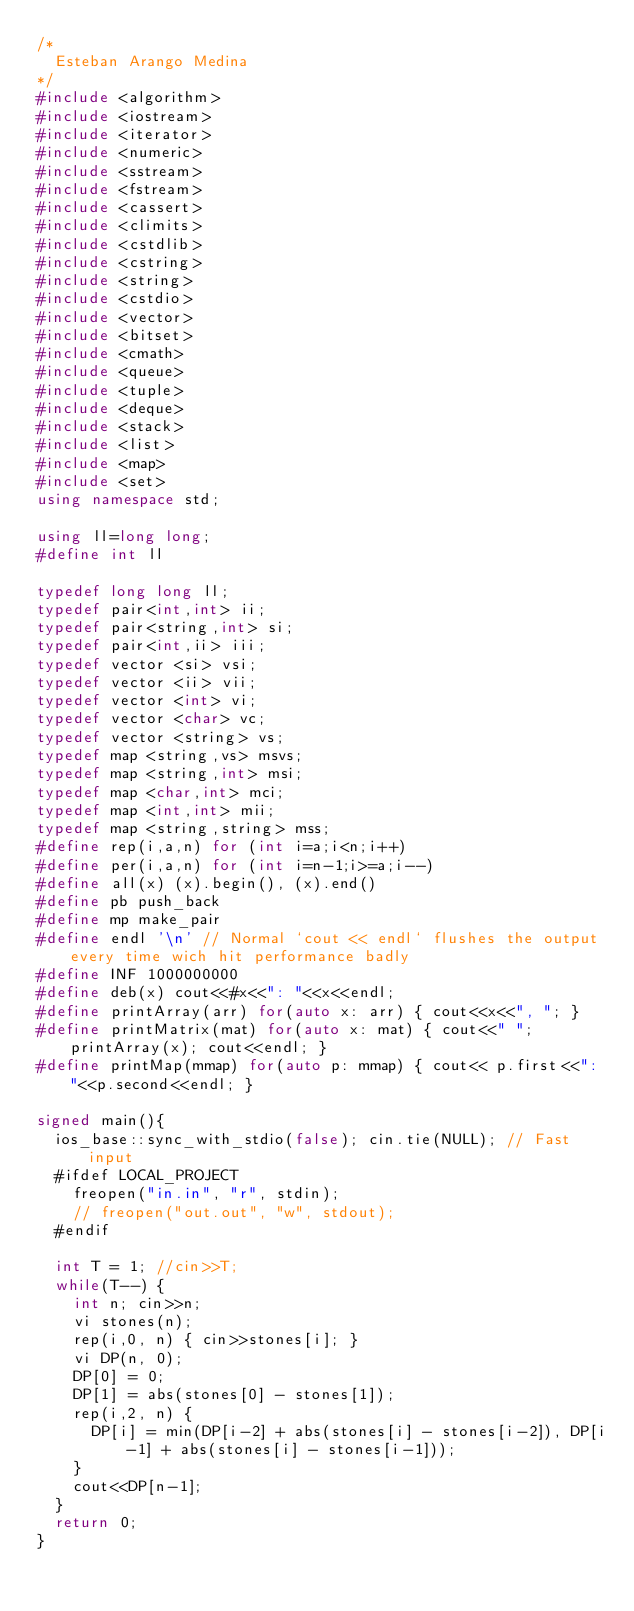<code> <loc_0><loc_0><loc_500><loc_500><_C++_>/*
  Esteban Arango Medina
*/
#include <algorithm>
#include <iostream>
#include <iterator>
#include <numeric>
#include <sstream>
#include <fstream>
#include <cassert>
#include <climits>
#include <cstdlib>
#include <cstring>
#include <string>
#include <cstdio>
#include <vector>
#include <bitset>
#include <cmath>
#include <queue>
#include <tuple>
#include <deque>
#include <stack>
#include <list>
#include <map>
#include <set>
using namespace std;

using ll=long long;
#define int ll

typedef long long ll;
typedef pair<int,int> ii;
typedef pair<string,int> si;
typedef pair<int,ii> iii;
typedef vector <si> vsi;
typedef vector <ii> vii;
typedef vector <int> vi;
typedef vector <char> vc;
typedef vector <string> vs;
typedef map <string,vs> msvs;
typedef map <string,int> msi;
typedef map <char,int> mci;
typedef map <int,int> mii;
typedef map <string,string> mss;
#define rep(i,a,n) for (int i=a;i<n;i++)
#define per(i,a,n) for (int i=n-1;i>=a;i--)
#define all(x) (x).begin(), (x).end()
#define pb push_back
#define mp make_pair
#define endl '\n' // Normal `cout << endl` flushes the output every time wich hit performance badly
#define INF 1000000000
#define deb(x) cout<<#x<<": "<<x<<endl;
#define printArray(arr) for(auto x: arr) { cout<<x<<", "; }
#define printMatrix(mat) for(auto x: mat) { cout<<" "; printArray(x); cout<<endl; }
#define printMap(mmap) for(auto p: mmap) { cout<< p.first<<": "<<p.second<<endl; }

signed main(){
  ios_base::sync_with_stdio(false); cin.tie(NULL); // Fast input
  #ifdef LOCAL_PROJECT
    freopen("in.in", "r", stdin);
    // freopen("out.out", "w", stdout);
  #endif

  int T = 1; //cin>>T;
  while(T--) {
    int n; cin>>n;
    vi stones(n);
    rep(i,0, n) { cin>>stones[i]; }
    vi DP(n, 0);
    DP[0] = 0;
    DP[1] = abs(stones[0] - stones[1]);
    rep(i,2, n) {
      DP[i] = min(DP[i-2] + abs(stones[i] - stones[i-2]), DP[i-1] + abs(stones[i] - stones[i-1]));
    }
    cout<<DP[n-1];
  }
  return 0;
}</code> 